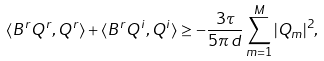<formula> <loc_0><loc_0><loc_500><loc_500>\langle B ^ { r } Q ^ { r } , Q ^ { r } \rangle + \langle B ^ { r } Q ^ { i } , Q ^ { i } \rangle \geq - \frac { 3 \tau } { 5 \pi \, d } \sum _ { m = 1 } ^ { M } | Q _ { m } | ^ { 2 } ,</formula> 